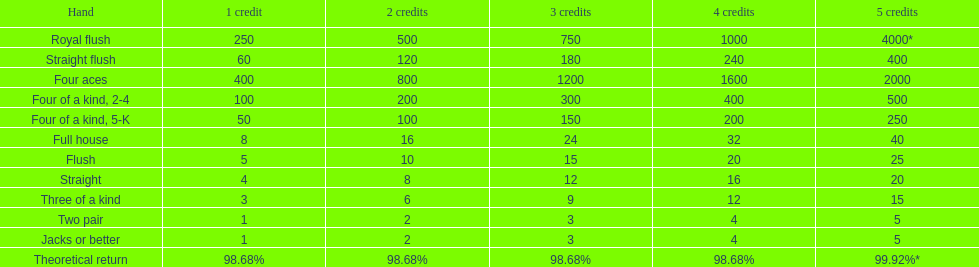What is the most superior four of a kind for a winning outcome? Four of a kind, 2-4. 